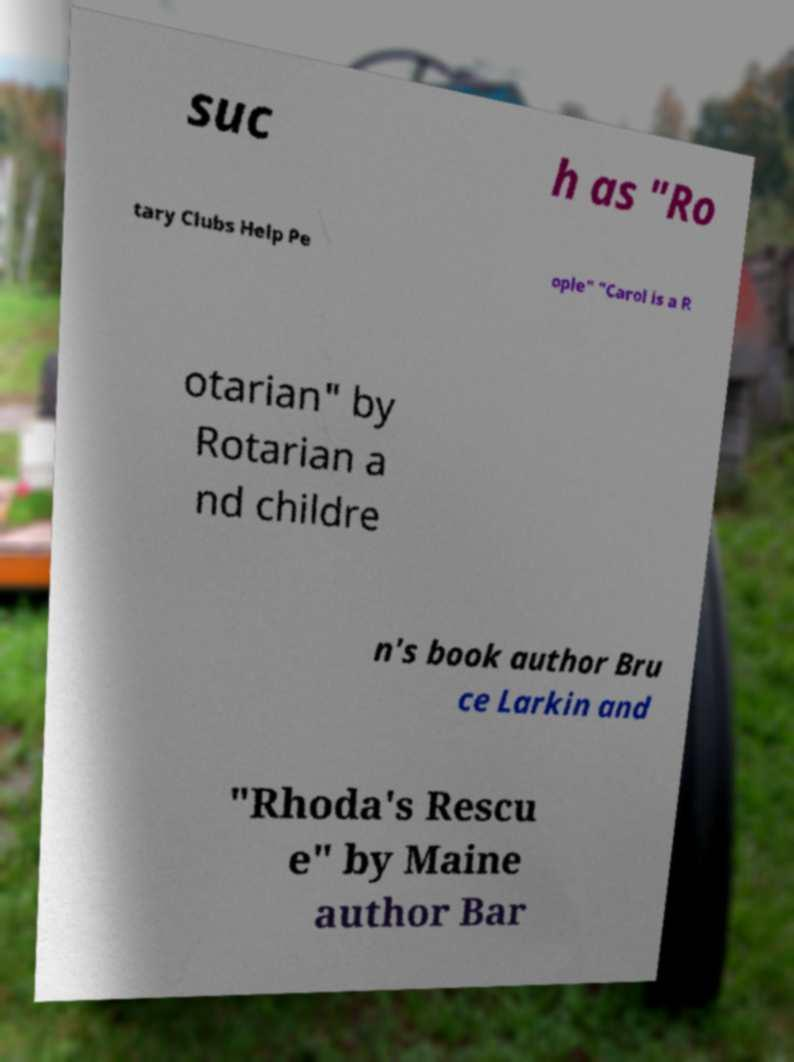For documentation purposes, I need the text within this image transcribed. Could you provide that? suc h as "Ro tary Clubs Help Pe ople" "Carol is a R otarian" by Rotarian a nd childre n's book author Bru ce Larkin and "Rhoda's Rescu e" by Maine author Bar 